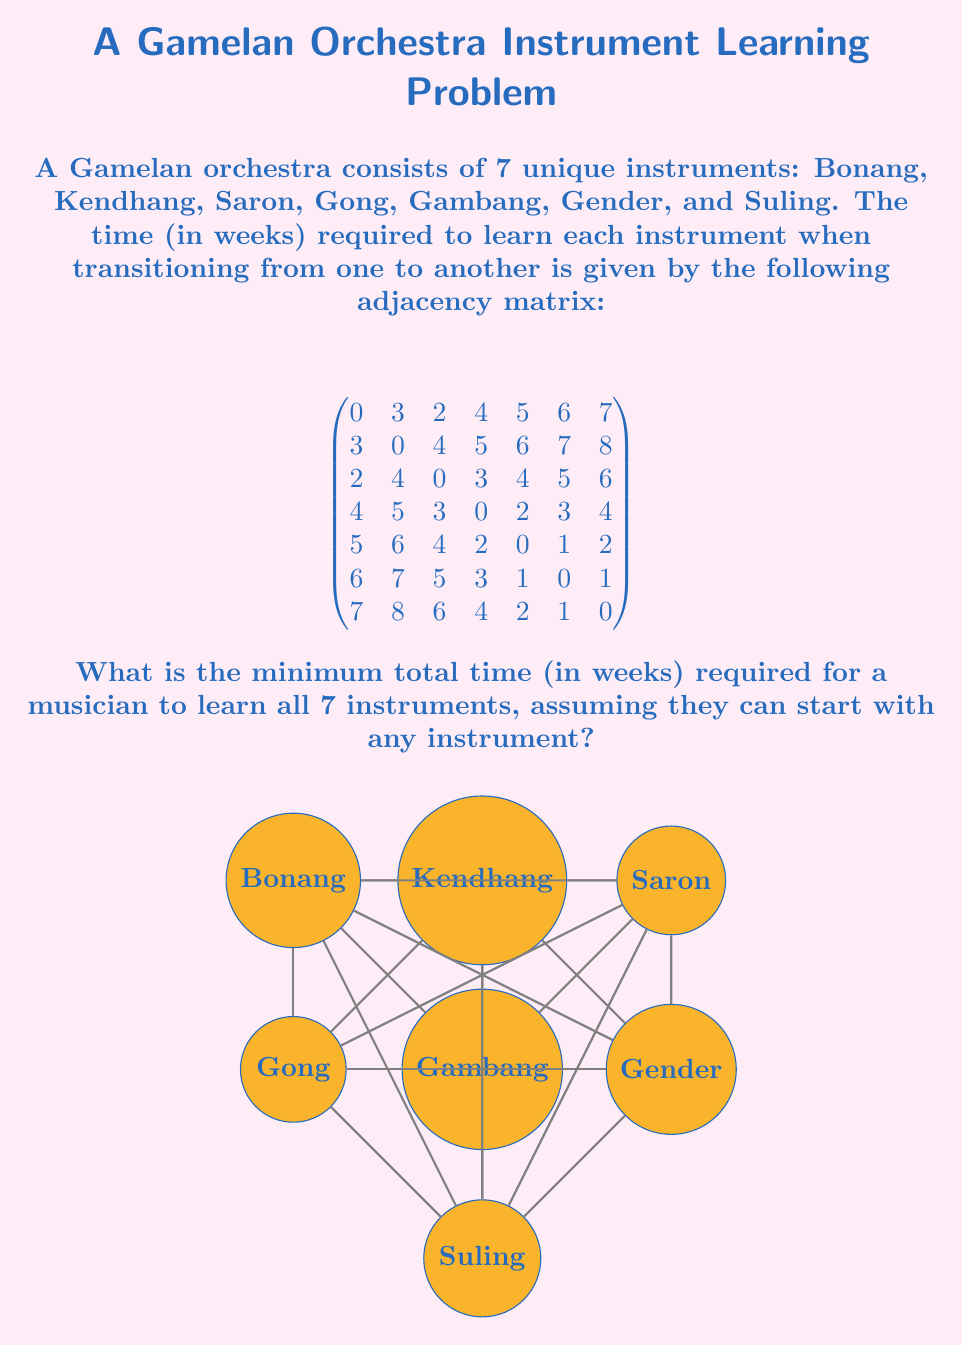Can you solve this math problem? To solve this problem, we need to find the minimum spanning tree (MST) of the graph represented by the adjacency matrix. The MST will give us the shortest path to learn all instruments.

Step 1: Identify the algorithm
We'll use Kruskal's algorithm to find the MST.

Step 2: Sort all edges in ascending order of weight
The sorted edges are:
(Gender, Suling): 1
(Gambang, Gender): 1
(Gambang, Suling): 2
(Gong, Gambang): 2
(Bonang, Saron): 2
(Gong, Gender): 3
(Bonang, Kendhang): 3

Step 3: Apply Kruskal's algorithm
1. Add (Gender, Suling): 1
2. Add (Gambang, Gender): 1
3. Add (Gong, Gambang): 2
4. Add (Bonang, Saron): 2
5. Add (Bonang, Kendhang): 3

After these steps, all 7 vertices are connected with 6 edges, forming the MST.

Step 4: Calculate the total weight
Sum of weights in MST = 1 + 1 + 2 + 2 + 3 = 9

Therefore, the minimum total time required to learn all 7 instruments is 9 weeks.
Answer: 9 weeks 